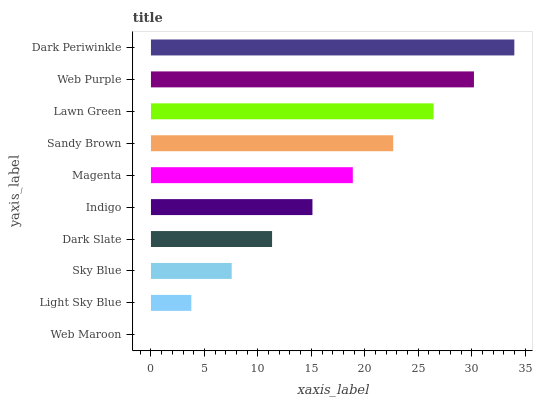Is Web Maroon the minimum?
Answer yes or no. Yes. Is Dark Periwinkle the maximum?
Answer yes or no. Yes. Is Light Sky Blue the minimum?
Answer yes or no. No. Is Light Sky Blue the maximum?
Answer yes or no. No. Is Light Sky Blue greater than Web Maroon?
Answer yes or no. Yes. Is Web Maroon less than Light Sky Blue?
Answer yes or no. Yes. Is Web Maroon greater than Light Sky Blue?
Answer yes or no. No. Is Light Sky Blue less than Web Maroon?
Answer yes or no. No. Is Magenta the high median?
Answer yes or no. Yes. Is Indigo the low median?
Answer yes or no. Yes. Is Sandy Brown the high median?
Answer yes or no. No. Is Sandy Brown the low median?
Answer yes or no. No. 